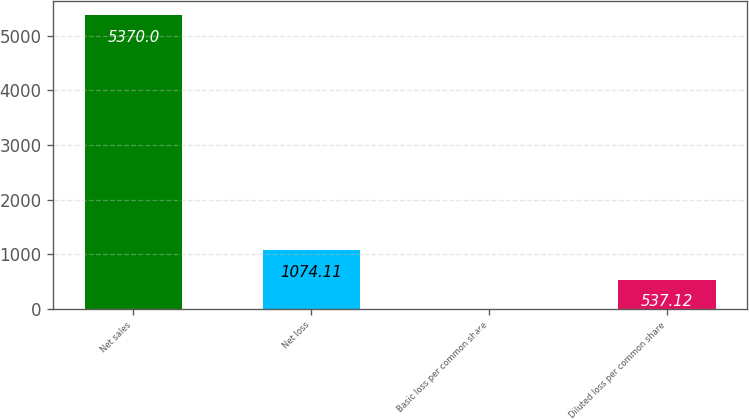Convert chart to OTSL. <chart><loc_0><loc_0><loc_500><loc_500><bar_chart><fcel>Net sales<fcel>Net loss<fcel>Basic loss per common share<fcel>Diluted loss per common share<nl><fcel>5370<fcel>1074.11<fcel>0.13<fcel>537.12<nl></chart> 